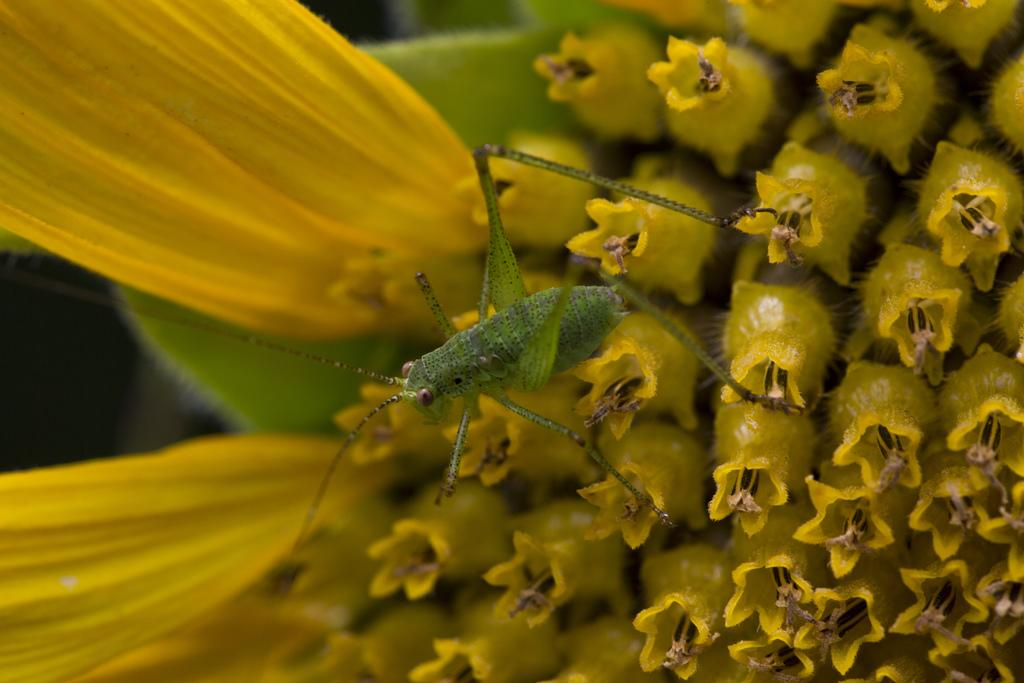What type of creature can be seen in the image? There is an insect in the image. What color is predominantly featured among the objects in the image? There are green color things in the image. What type of battle is taking place in the image? There is no battle present in the image; it features an insect and green color things. Who is the winner of the competition in the image? There is no competition present in the image; it features an insect and green color things. 